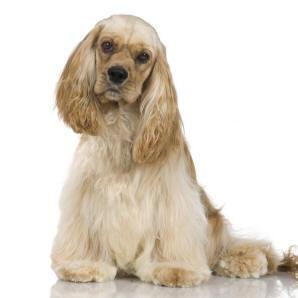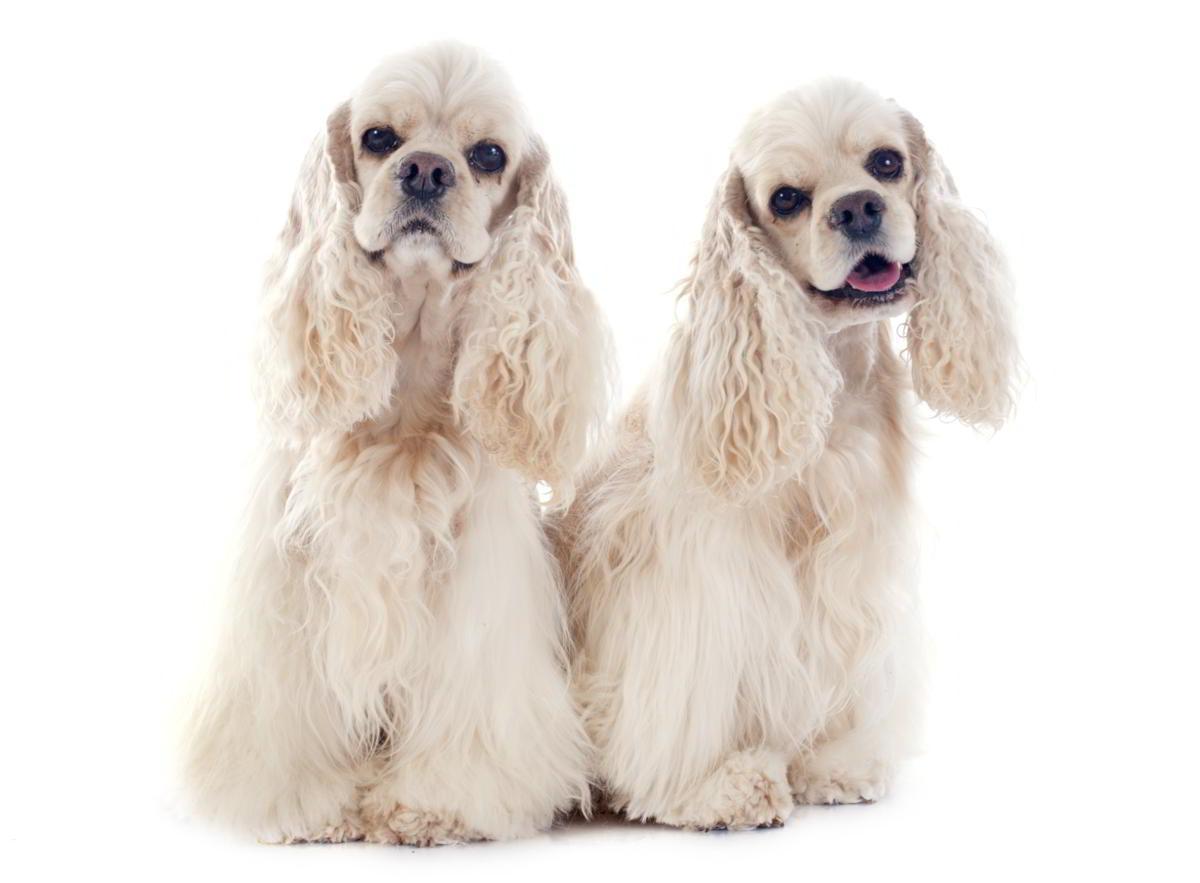The first image is the image on the left, the second image is the image on the right. For the images displayed, is the sentence "The dog in the image on the left is standing on all fours." factually correct? Answer yes or no. No. 